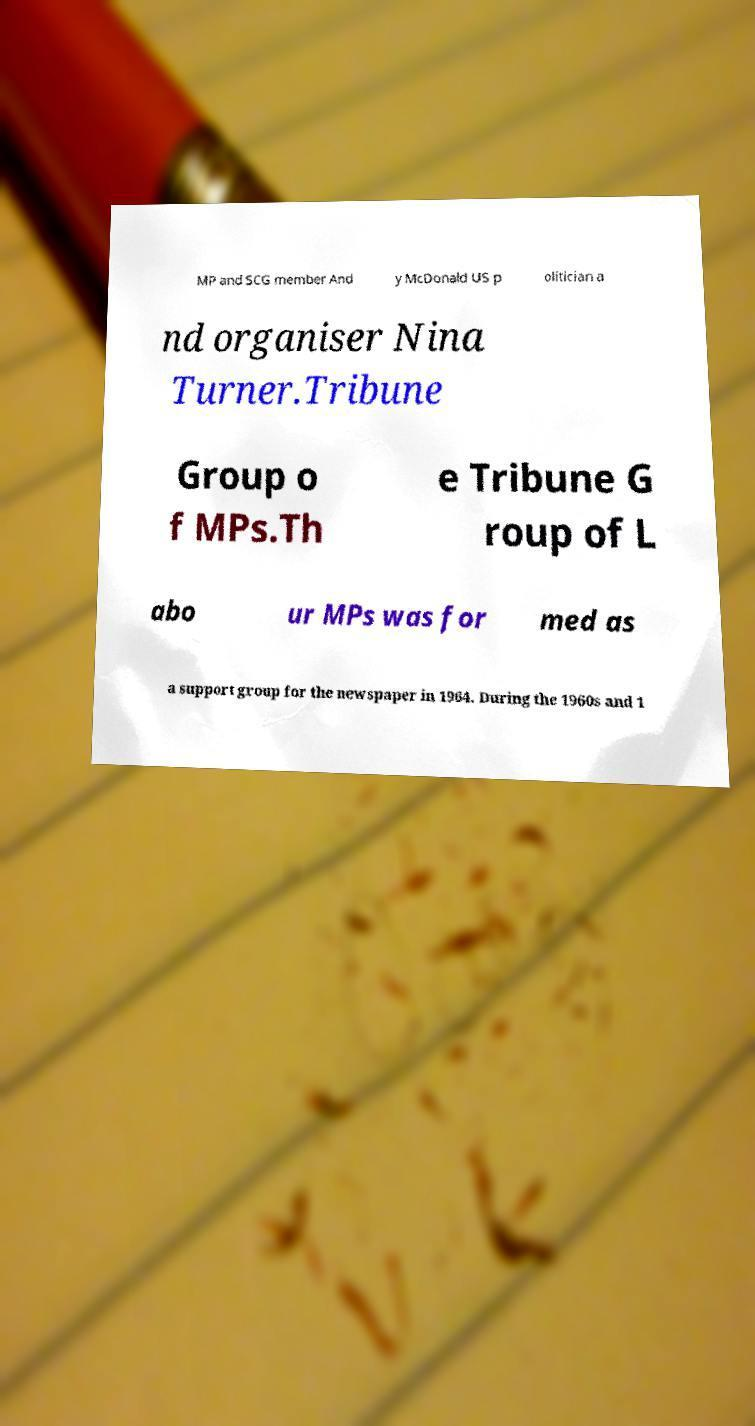Please read and relay the text visible in this image. What does it say? MP and SCG member And y McDonald US p olitician a nd organiser Nina Turner.Tribune Group o f MPs.Th e Tribune G roup of L abo ur MPs was for med as a support group for the newspaper in 1964. During the 1960s and 1 